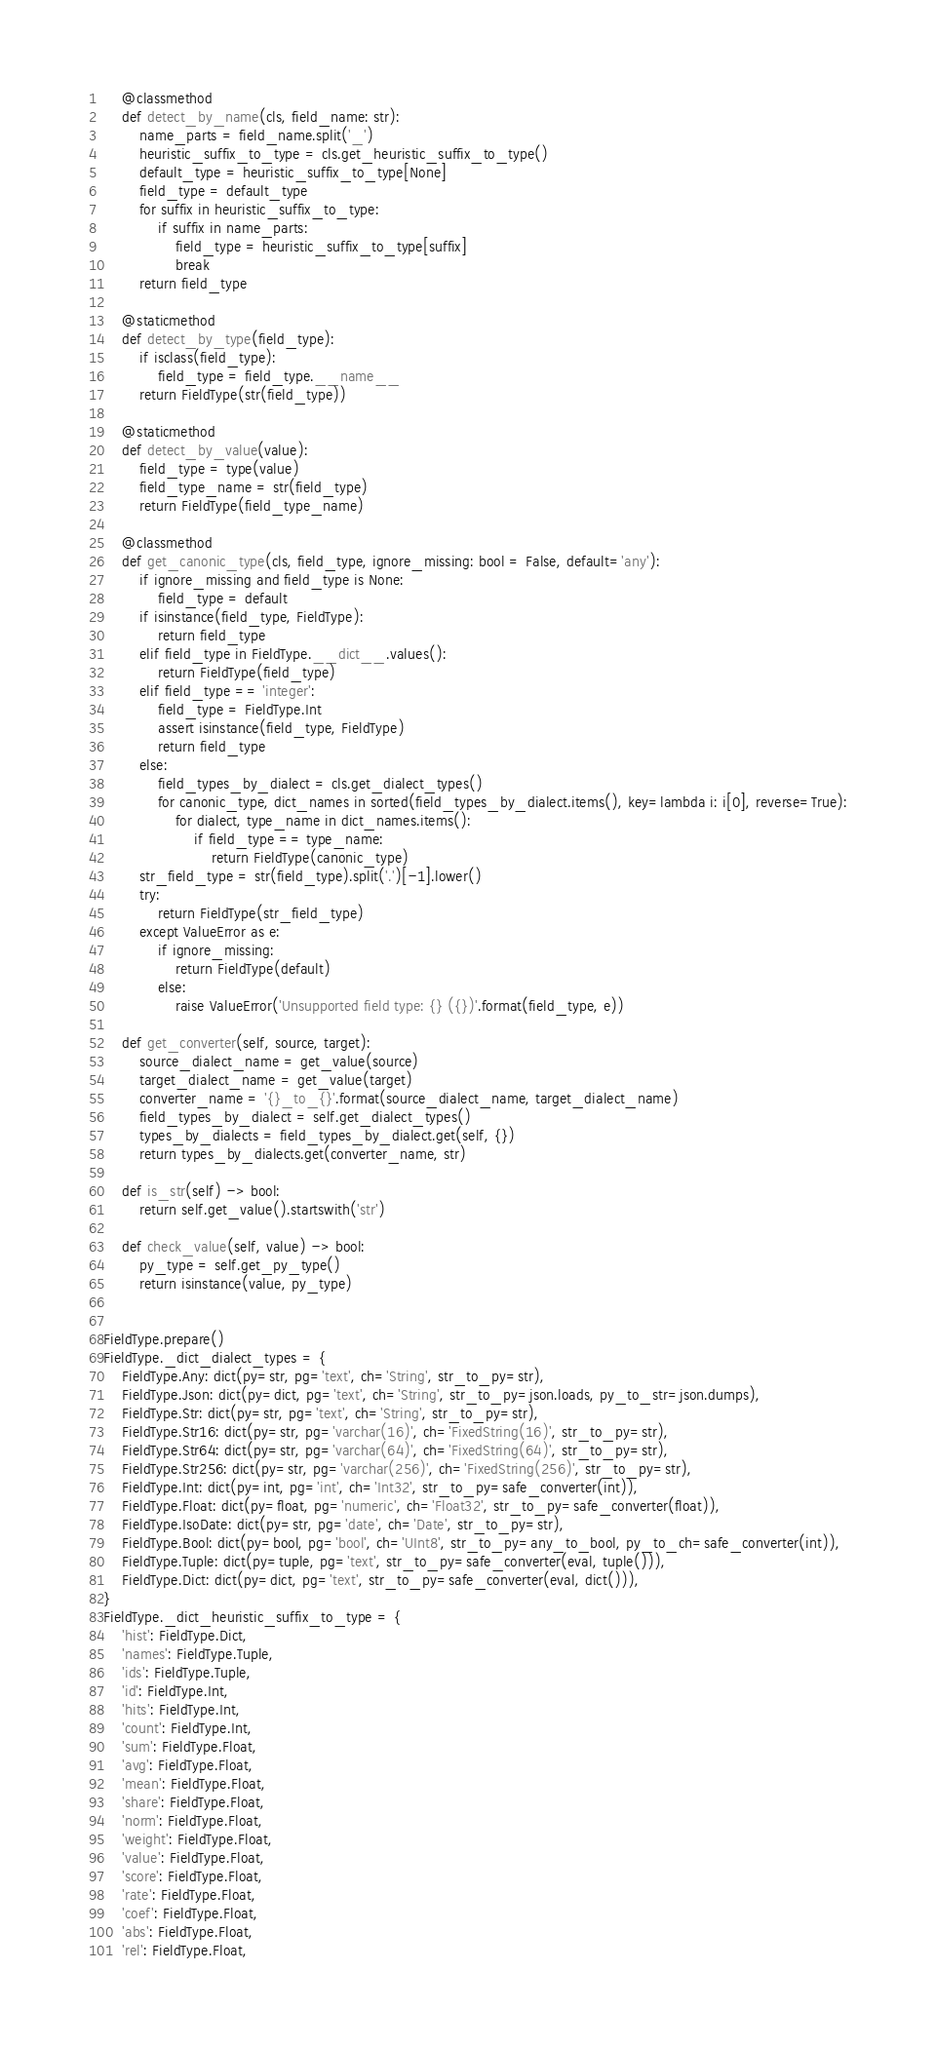<code> <loc_0><loc_0><loc_500><loc_500><_Python_>
    @classmethod
    def detect_by_name(cls, field_name: str):
        name_parts = field_name.split('_')
        heuristic_suffix_to_type = cls.get_heuristic_suffix_to_type()
        default_type = heuristic_suffix_to_type[None]
        field_type = default_type
        for suffix in heuristic_suffix_to_type:
            if suffix in name_parts:
                field_type = heuristic_suffix_to_type[suffix]
                break
        return field_type

    @staticmethod
    def detect_by_type(field_type):
        if isclass(field_type):
            field_type = field_type.__name__
        return FieldType(str(field_type))

    @staticmethod
    def detect_by_value(value):
        field_type = type(value)
        field_type_name = str(field_type)
        return FieldType(field_type_name)

    @classmethod
    def get_canonic_type(cls, field_type, ignore_missing: bool = False, default='any'):
        if ignore_missing and field_type is None:
            field_type = default
        if isinstance(field_type, FieldType):
            return field_type
        elif field_type in FieldType.__dict__.values():
            return FieldType(field_type)
        elif field_type == 'integer':
            field_type = FieldType.Int
            assert isinstance(field_type, FieldType)
            return field_type
        else:
            field_types_by_dialect = cls.get_dialect_types()
            for canonic_type, dict_names in sorted(field_types_by_dialect.items(), key=lambda i: i[0], reverse=True):
                for dialect, type_name in dict_names.items():
                    if field_type == type_name:
                        return FieldType(canonic_type)
        str_field_type = str(field_type).split('.')[-1].lower()
        try:
            return FieldType(str_field_type)
        except ValueError as e:
            if ignore_missing:
                return FieldType(default)
            else:
                raise ValueError('Unsupported field type: {} ({})'.format(field_type, e))

    def get_converter(self, source, target):
        source_dialect_name = get_value(source)
        target_dialect_name = get_value(target)
        converter_name = '{}_to_{}'.format(source_dialect_name, target_dialect_name)
        field_types_by_dialect = self.get_dialect_types()
        types_by_dialects = field_types_by_dialect.get(self, {})
        return types_by_dialects.get(converter_name, str)

    def is_str(self) -> bool:
        return self.get_value().startswith('str')

    def check_value(self, value) -> bool:
        py_type = self.get_py_type()
        return isinstance(value, py_type)


FieldType.prepare()
FieldType._dict_dialect_types = {
    FieldType.Any: dict(py=str, pg='text', ch='String', str_to_py=str),
    FieldType.Json: dict(py=dict, pg='text', ch='String', str_to_py=json.loads, py_to_str=json.dumps),
    FieldType.Str: dict(py=str, pg='text', ch='String', str_to_py=str),
    FieldType.Str16: dict(py=str, pg='varchar(16)', ch='FixedString(16)', str_to_py=str),
    FieldType.Str64: dict(py=str, pg='varchar(64)', ch='FixedString(64)', str_to_py=str),
    FieldType.Str256: dict(py=str, pg='varchar(256)', ch='FixedString(256)', str_to_py=str),
    FieldType.Int: dict(py=int, pg='int', ch='Int32', str_to_py=safe_converter(int)),
    FieldType.Float: dict(py=float, pg='numeric', ch='Float32', str_to_py=safe_converter(float)),
    FieldType.IsoDate: dict(py=str, pg='date', ch='Date', str_to_py=str),
    FieldType.Bool: dict(py=bool, pg='bool', ch='UInt8', str_to_py=any_to_bool, py_to_ch=safe_converter(int)),
    FieldType.Tuple: dict(py=tuple, pg='text', str_to_py=safe_converter(eval, tuple())),
    FieldType.Dict: dict(py=dict, pg='text', str_to_py=safe_converter(eval, dict())),
}
FieldType._dict_heuristic_suffix_to_type = {
    'hist': FieldType.Dict,
    'names': FieldType.Tuple,
    'ids': FieldType.Tuple,
    'id': FieldType.Int,
    'hits': FieldType.Int,
    'count': FieldType.Int,
    'sum': FieldType.Float,
    'avg': FieldType.Float,
    'mean': FieldType.Float,
    'share': FieldType.Float,
    'norm': FieldType.Float,
    'weight': FieldType.Float,
    'value': FieldType.Float,
    'score': FieldType.Float,
    'rate': FieldType.Float,
    'coef': FieldType.Float,
    'abs': FieldType.Float,
    'rel': FieldType.Float,</code> 